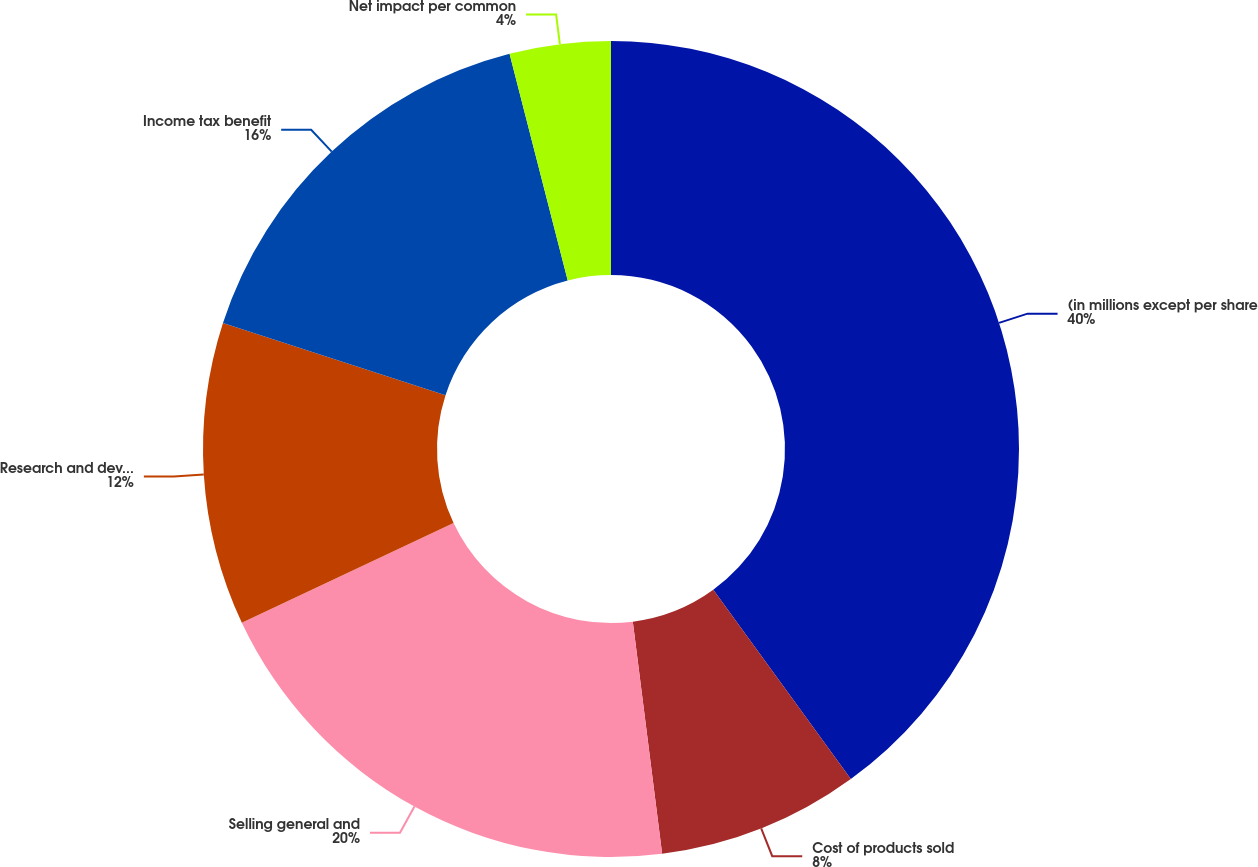Convert chart to OTSL. <chart><loc_0><loc_0><loc_500><loc_500><pie_chart><fcel>(in millions except per share<fcel>Cost of products sold<fcel>Selling general and<fcel>Research and development<fcel>Income tax benefit<fcel>Net impact per common<nl><fcel>40.0%<fcel>8.0%<fcel>20.0%<fcel>12.0%<fcel>16.0%<fcel>4.0%<nl></chart> 